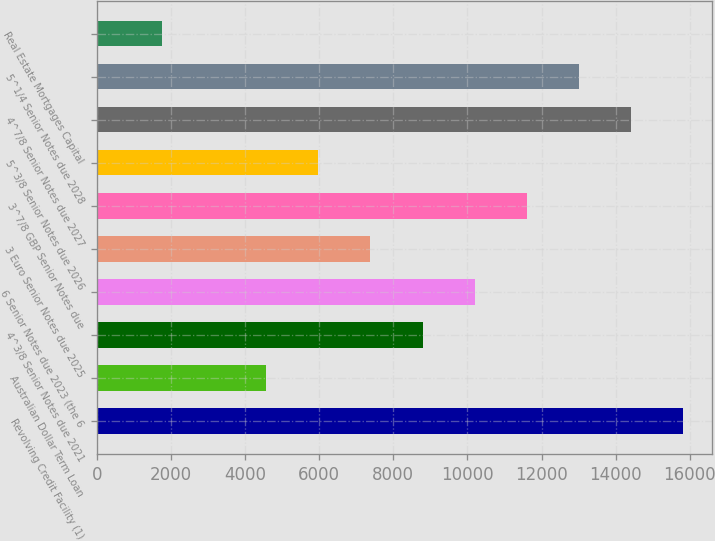Convert chart to OTSL. <chart><loc_0><loc_0><loc_500><loc_500><bar_chart><fcel>Revolving Credit Facility (1)<fcel>Australian Dollar Term Loan<fcel>4^3/8 Senior Notes due 2021<fcel>6 Senior Notes due 2023 (the 6<fcel>3 Euro Senior Notes due 2025<fcel>3^7/8 GBP Senior Notes due<fcel>5^3/8 Senior Notes due 2026<fcel>4^7/8 Senior Notes due 2027<fcel>5^1/4 Senior Notes due 2028<fcel>Real Estate Mortgages Capital<nl><fcel>15812.1<fcel>4571.3<fcel>8786.6<fcel>10191.7<fcel>7381.5<fcel>11596.8<fcel>5976.4<fcel>14407<fcel>13001.9<fcel>1761.1<nl></chart> 